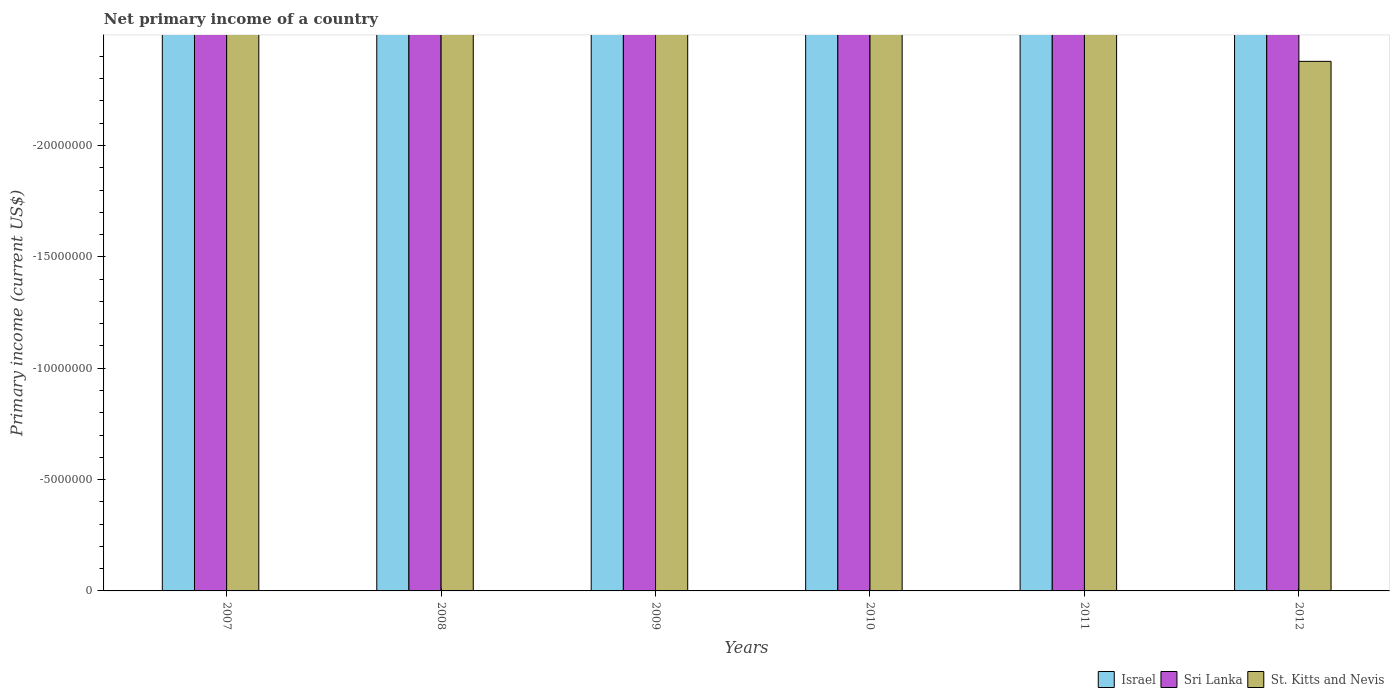How many different coloured bars are there?
Keep it short and to the point. 0. How many bars are there on the 2nd tick from the left?
Offer a terse response. 0. In how many cases, is the number of bars for a given year not equal to the number of legend labels?
Give a very brief answer. 6. Across all years, what is the minimum primary income in Sri Lanka?
Provide a succinct answer. 0. What is the total primary income in Israel in the graph?
Keep it short and to the point. 0. In how many years, is the primary income in Sri Lanka greater than the average primary income in Sri Lanka taken over all years?
Give a very brief answer. 0. How many bars are there?
Keep it short and to the point. 0. Are all the bars in the graph horizontal?
Give a very brief answer. No. How many years are there in the graph?
Offer a terse response. 6. What is the difference between two consecutive major ticks on the Y-axis?
Make the answer very short. 5.00e+06. Are the values on the major ticks of Y-axis written in scientific E-notation?
Your response must be concise. No. Does the graph contain any zero values?
Provide a short and direct response. Yes. Where does the legend appear in the graph?
Your response must be concise. Bottom right. How are the legend labels stacked?
Give a very brief answer. Horizontal. What is the title of the graph?
Offer a very short reply. Net primary income of a country. What is the label or title of the Y-axis?
Offer a terse response. Primary income (current US$). What is the Primary income (current US$) of Sri Lanka in 2007?
Your response must be concise. 0. What is the Primary income (current US$) in St. Kitts and Nevis in 2008?
Your response must be concise. 0. What is the Primary income (current US$) in Israel in 2009?
Keep it short and to the point. 0. What is the Primary income (current US$) in Israel in 2010?
Your answer should be compact. 0. What is the Primary income (current US$) in Sri Lanka in 2011?
Provide a short and direct response. 0. What is the Primary income (current US$) in St. Kitts and Nevis in 2011?
Ensure brevity in your answer.  0. What is the Primary income (current US$) in St. Kitts and Nevis in 2012?
Your answer should be compact. 0. What is the total Primary income (current US$) in Sri Lanka in the graph?
Offer a terse response. 0. What is the average Primary income (current US$) in Israel per year?
Provide a succinct answer. 0. 